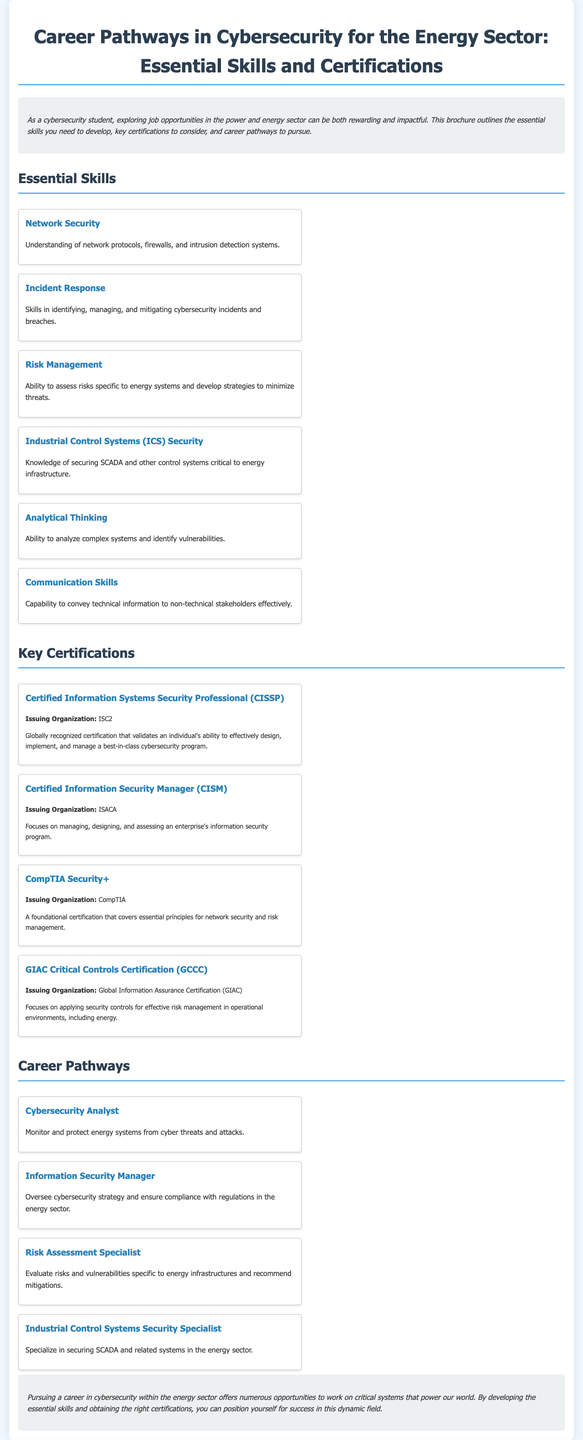What is the title of the brochure? The title is explicitly stated at the top of the document.
Answer: Career Pathways in Cybersecurity for the Energy Sector: Essential Skills and Certifications How many essential skills are listed in the document? The document provides a clear count of essential skills mentioned.
Answer: Six What certification is issued by ISC2? The issuing organization for the certification gives away its name easily.
Answer: Certified Information Systems Security Professional (CISSP) Which career pathway focuses on securing SCADA systems? This information can be found under the career pathways section.
Answer: Industrial Control Systems Security Specialist What are the two organizations that issue the CISM and GIAC Critical Controls Certification? These organizations can be identified under the relevant certification descriptions.
Answer: ISACA and Global Information Assurance Certification (GIAC) What is a key skill needed for analyzing vulnerabilities? The specific skill related to the ability to analyze is clearly stated in the skills section.
Answer: Analytical Thinking What skill is essential for communicating with non-technical stakeholders? This question relates to communication abilities highlighted in the document.
Answer: Communication Skills Which certification focuses on risk management in operational environments? This can be deduced from the description of GIAC Critical Controls Certification (GCCC).
Answer: GIAC Critical Controls Certification (GCCC) 